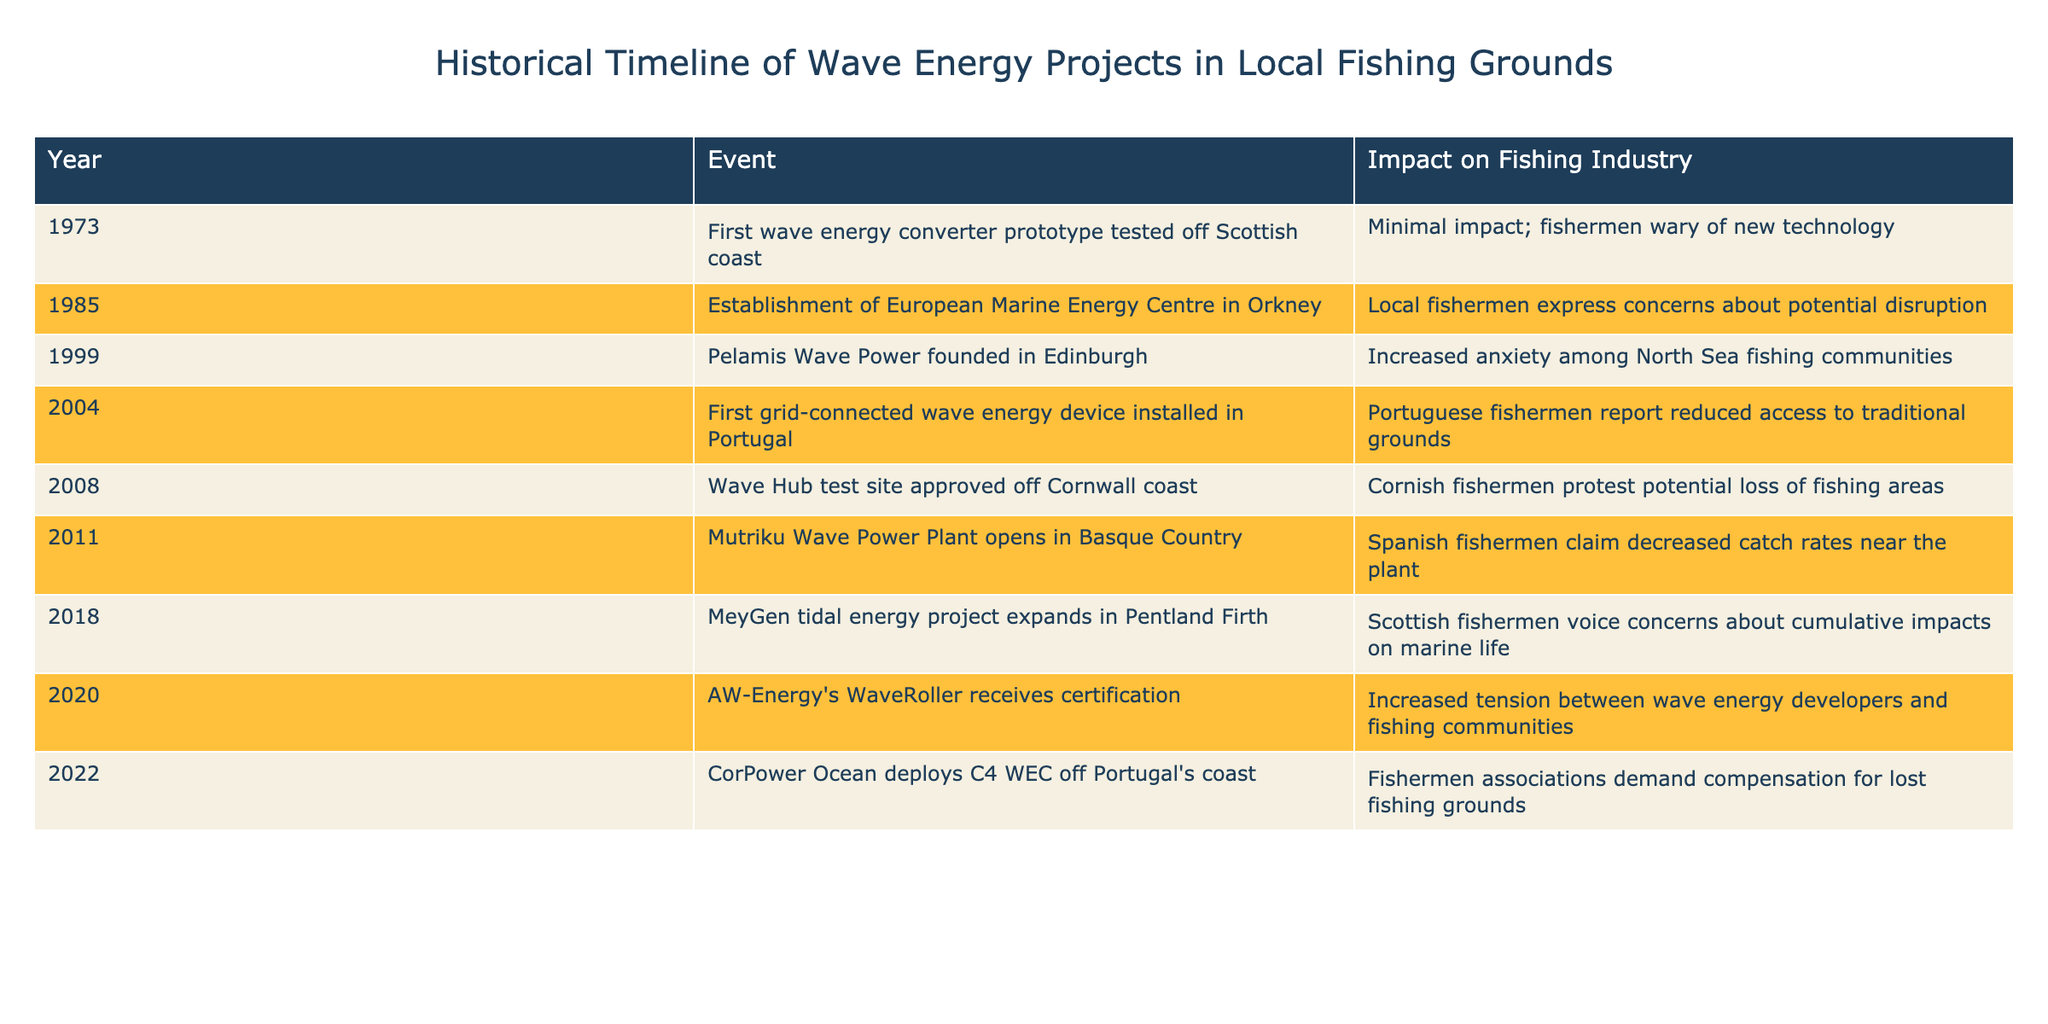What year did the first wave energy converter prototype get tested? The table shows that the first wave energy converter prototype was tested off the Scottish coast in 1973.
Answer: 1973 In what year did the Portuguese fishermen report reduced access to traditional grounds due to wave energy projects? According to the table, Portuguese fishermen reported reduced access in the year 2004 when the first grid-connected wave energy device was installed in Portugal.
Answer: 2004 How many significant events were noted after 2010? From the table, the events listed after 2010 are three: the opening of the Mutriku Wave Power Plant in 2011, the expansion of the MeyGen tidal energy project in 2018, and the certification of AW-Energy's WaveRoller in 2020. Thus, there are three events.
Answer: 3 Was there an increase in anxiety among North Sea fishing communities in 1999? Yes, according to the table, Pelamis Wave Power was founded in 1999, which led to increased anxiety among North Sea fishing communities.
Answer: Yes Which event had the most direct reported impact on fishermen's catch rates, and what was the year? The event that had the most direct reported impact on fishermen's catch rates was the opening of the Mutriku Wave Power Plant in 2011, where Spanish fishermen claimed decreased catch rates near the plant.
Answer: 2011 What is the year with the earliest documented concerns from local fishermen regarding wave energy? The earliest documented concerns from local fishermen regarding wave energy were noted in 1985, with the establishment of the European Marine Energy Centre in Orkney.
Answer: 1985 How many years between the establishment of the European Marine Energy Centre in 1985 and the first wave energy device installed in 2004? To find the number of years between these two events, subtract 1985 from 2004, which gives 19 years.
Answer: 19 years Did the fishermen associations demand compensation in 2022? Yes, the table states that in 2022, fishermen associations demanded compensation for lost fishing grounds after CorPower Ocean deployed the C4 WEC off Portugal's coast.
Answer: Yes How many events recorded a negative impact on local fishing as noted in the table? The events that recorded a negative impact on local fishing are those in 2004, 2008, 2011, and 2020, totaling four events.
Answer: 4 